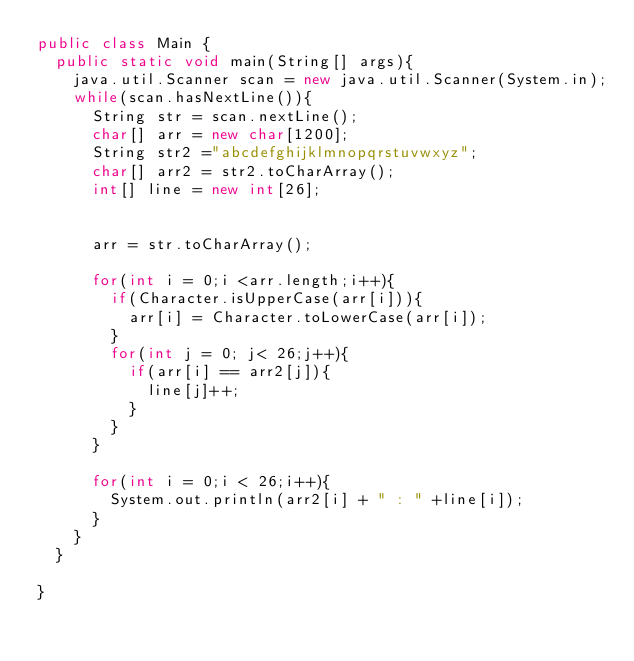Convert code to text. <code><loc_0><loc_0><loc_500><loc_500><_Java_>public class Main {
	public static void main(String[] args){
		java.util.Scanner scan = new java.util.Scanner(System.in);
		while(scan.hasNextLine()){
			String str = scan.nextLine();
			char[] arr = new char[1200];
			String str2 ="abcdefghijklmnopqrstuvwxyz";
			char[] arr2 = str2.toCharArray();
			int[] line = new int[26];


			arr = str.toCharArray();

			for(int i = 0;i <arr.length;i++){
				if(Character.isUpperCase(arr[i])){
					arr[i] = Character.toLowerCase(arr[i]);
				}
				for(int j = 0; j< 26;j++){
					if(arr[i] == arr2[j]){
						line[j]++;
					}
				}
			}

			for(int i = 0;i < 26;i++){
				System.out.println(arr2[i] + " : " +line[i]);
			}
		}
	}

}</code> 